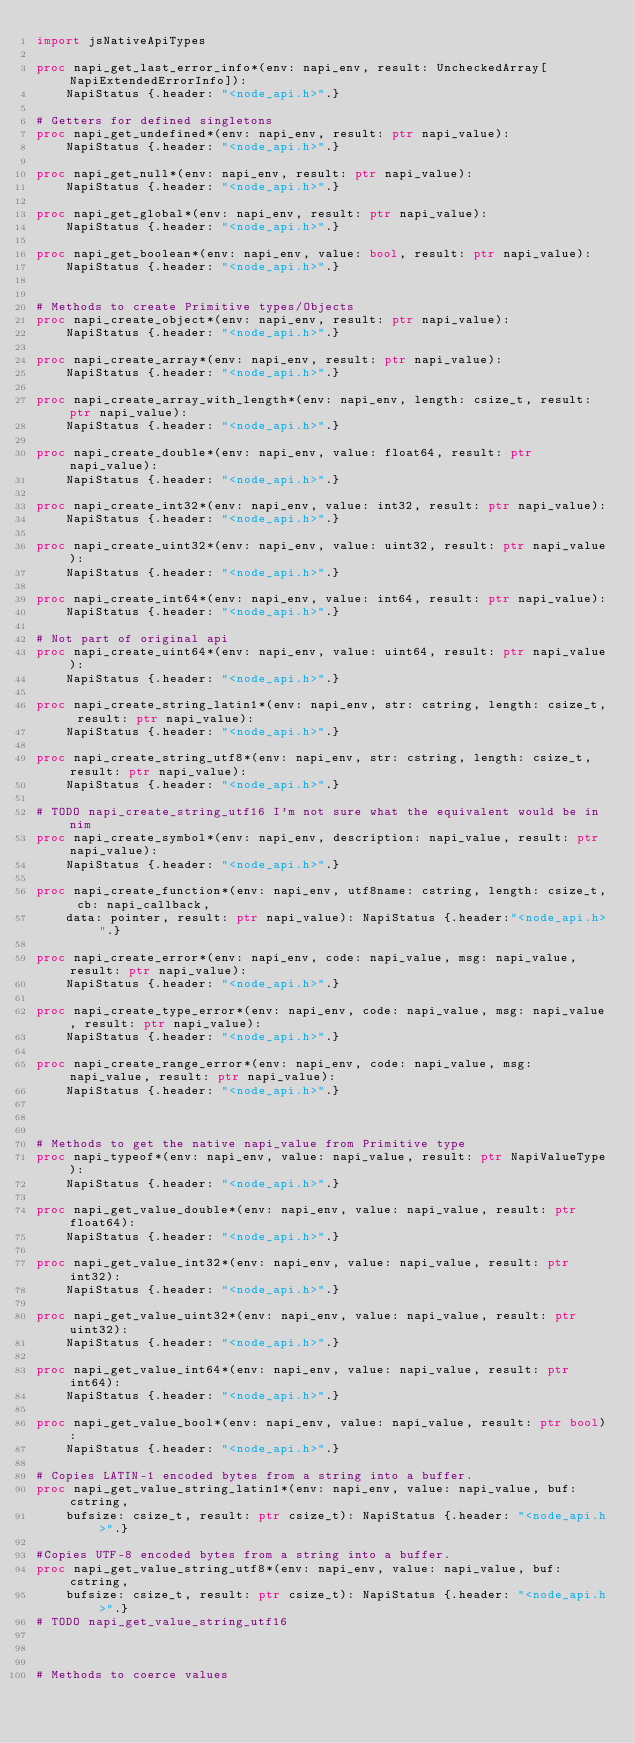Convert code to text. <code><loc_0><loc_0><loc_500><loc_500><_Nim_>import jsNativeApiTypes

proc napi_get_last_error_info*(env: napi_env, result: UncheckedArray[NapiExtendedErrorInfo]):
    NapiStatus {.header: "<node_api.h>".}

# Getters for defined singletons
proc napi_get_undefined*(env: napi_env, result: ptr napi_value):
    NapiStatus {.header: "<node_api.h>".}

proc napi_get_null*(env: napi_env, result: ptr napi_value):
    NapiStatus {.header: "<node_api.h>".}

proc napi_get_global*(env: napi_env, result: ptr napi_value):
    NapiStatus {.header: "<node_api.h>".}

proc napi_get_boolean*(env: napi_env, value: bool, result: ptr napi_value):
    NapiStatus {.header: "<node_api.h>".}


# Methods to create Primitive types/Objects
proc napi_create_object*(env: napi_env, result: ptr napi_value):
    NapiStatus {.header: "<node_api.h>".}

proc napi_create_array*(env: napi_env, result: ptr napi_value):
    NapiStatus {.header: "<node_api.h>".}

proc napi_create_array_with_length*(env: napi_env, length: csize_t, result: ptr napi_value):
    NapiStatus {.header: "<node_api.h>".}

proc napi_create_double*(env: napi_env, value: float64, result: ptr napi_value):
    NapiStatus {.header: "<node_api.h>".}

proc napi_create_int32*(env: napi_env, value: int32, result: ptr napi_value):
    NapiStatus {.header: "<node_api.h>".}

proc napi_create_uint32*(env: napi_env, value: uint32, result: ptr napi_value):
    NapiStatus {.header: "<node_api.h>".}

proc napi_create_int64*(env: napi_env, value: int64, result: ptr napi_value):
    NapiStatus {.header: "<node_api.h>".}

# Not part of original api
proc napi_create_uint64*(env: napi_env, value: uint64, result: ptr napi_value):
    NapiStatus {.header: "<node_api.h>".}

proc napi_create_string_latin1*(env: napi_env, str: cstring, length: csize_t, result: ptr napi_value):
    NapiStatus {.header: "<node_api.h>".}

proc napi_create_string_utf8*(env: napi_env, str: cstring, length: csize_t, result: ptr napi_value):
    NapiStatus {.header: "<node_api.h>".}

# TODO napi_create_string_utf16 I'm not sure what the equivalent would be in nim
proc napi_create_symbol*(env: napi_env, description: napi_value, result: ptr napi_value):
    NapiStatus {.header: "<node_api.h>".}

proc napi_create_function*(env: napi_env, utf8name: cstring, length: csize_t, cb: napi_callback,
    data: pointer, result: ptr napi_value): NapiStatus {.header:"<node_api.h>".}

proc napi_create_error*(env: napi_env, code: napi_value, msg: napi_value, result: ptr napi_value):
    NapiStatus {.header: "<node_api.h>".}

proc napi_create_type_error*(env: napi_env, code: napi_value, msg: napi_value, result: ptr napi_value):
    NapiStatus {.header: "<node_api.h>".}

proc napi_create_range_error*(env: napi_env, code: napi_value, msg: napi_value, result: ptr napi_value):
    NapiStatus {.header: "<node_api.h>".}



# Methods to get the native napi_value from Primitive type
proc napi_typeof*(env: napi_env, value: napi_value, result: ptr NapiValueType):
    NapiStatus {.header: "<node_api.h>".}

proc napi_get_value_double*(env: napi_env, value: napi_value, result: ptr float64):
    NapiStatus {.header: "<node_api.h>".}

proc napi_get_value_int32*(env: napi_env, value: napi_value, result: ptr int32):
    NapiStatus {.header: "<node_api.h>".}

proc napi_get_value_uint32*(env: napi_env, value: napi_value, result: ptr uint32):
    NapiStatus {.header: "<node_api.h>".}

proc napi_get_value_int64*(env: napi_env, value: napi_value, result: ptr int64):
    NapiStatus {.header: "<node_api.h>".}

proc napi_get_value_bool*(env: napi_env, value: napi_value, result: ptr bool):
    NapiStatus {.header: "<node_api.h>".}

# Copies LATIN-1 encoded bytes from a string into a buffer.
proc napi_get_value_string_latin1*(env: napi_env, value: napi_value, buf: cstring,
    bufsize: csize_t, result: ptr csize_t): NapiStatus {.header: "<node_api.h>".}

#Copies UTF-8 encoded bytes from a string into a buffer.
proc napi_get_value_string_utf8*(env: napi_env, value: napi_value, buf: cstring,
    bufsize: csize_t, result: ptr csize_t): NapiStatus {.header: "<node_api.h>".}
# TODO napi_get_value_string_utf16



# Methods to coerce values</code> 